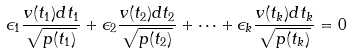<formula> <loc_0><loc_0><loc_500><loc_500>\epsilon _ { 1 } \frac { v ( t _ { 1 } ) d t _ { 1 } } { \sqrt { p ( t _ { 1 } ) } } + \epsilon _ { 2 } \frac { v ( t _ { 2 } ) d t _ { 2 } } { \sqrt { p ( t _ { 2 } ) } } + \dots + \epsilon _ { k } \frac { v ( t _ { k } ) d t _ { k } } { \sqrt { p ( t _ { k } ) } } = 0</formula> 